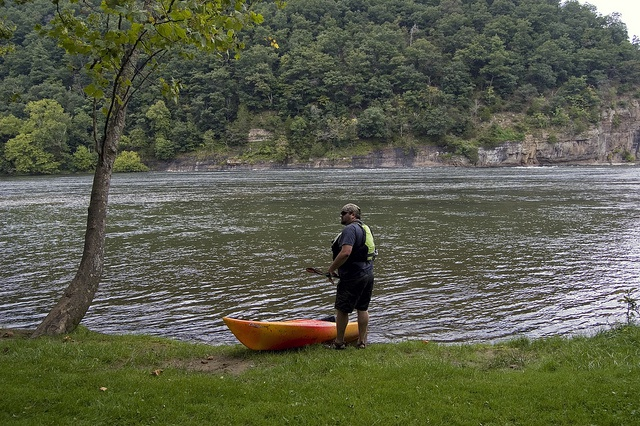Describe the objects in this image and their specific colors. I can see people in darkgreen, black, and gray tones and boat in darkgreen, maroon, black, lightpink, and brown tones in this image. 